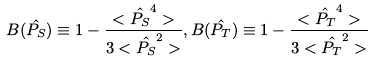Convert formula to latex. <formula><loc_0><loc_0><loc_500><loc_500>B ( \hat { P _ { S } } ) \equiv 1 - \frac { < \hat { P _ { S } } ^ { 4 } > } { 3 < \hat { P _ { S } } ^ { 2 } > } , B ( \hat { P _ { T } } ) \equiv 1 - \frac { < \hat { P _ { T } } ^ { 4 } > } { 3 < \hat { P _ { T } } ^ { 2 } > }</formula> 